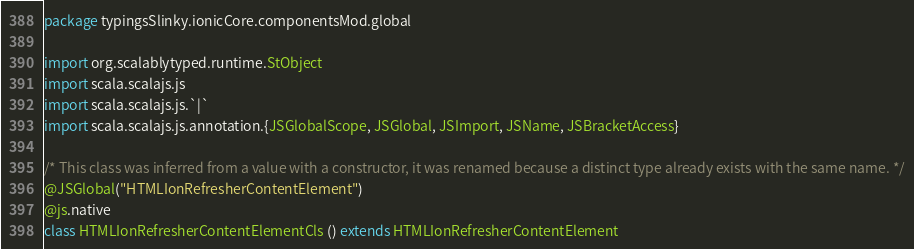Convert code to text. <code><loc_0><loc_0><loc_500><loc_500><_Scala_>package typingsSlinky.ionicCore.componentsMod.global

import org.scalablytyped.runtime.StObject
import scala.scalajs.js
import scala.scalajs.js.`|`
import scala.scalajs.js.annotation.{JSGlobalScope, JSGlobal, JSImport, JSName, JSBracketAccess}

/* This class was inferred from a value with a constructor, it was renamed because a distinct type already exists with the same name. */
@JSGlobal("HTMLIonRefresherContentElement")
@js.native
class HTMLIonRefresherContentElementCls () extends HTMLIonRefresherContentElement
</code> 